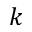Convert formula to latex. <formula><loc_0><loc_0><loc_500><loc_500>k</formula> 